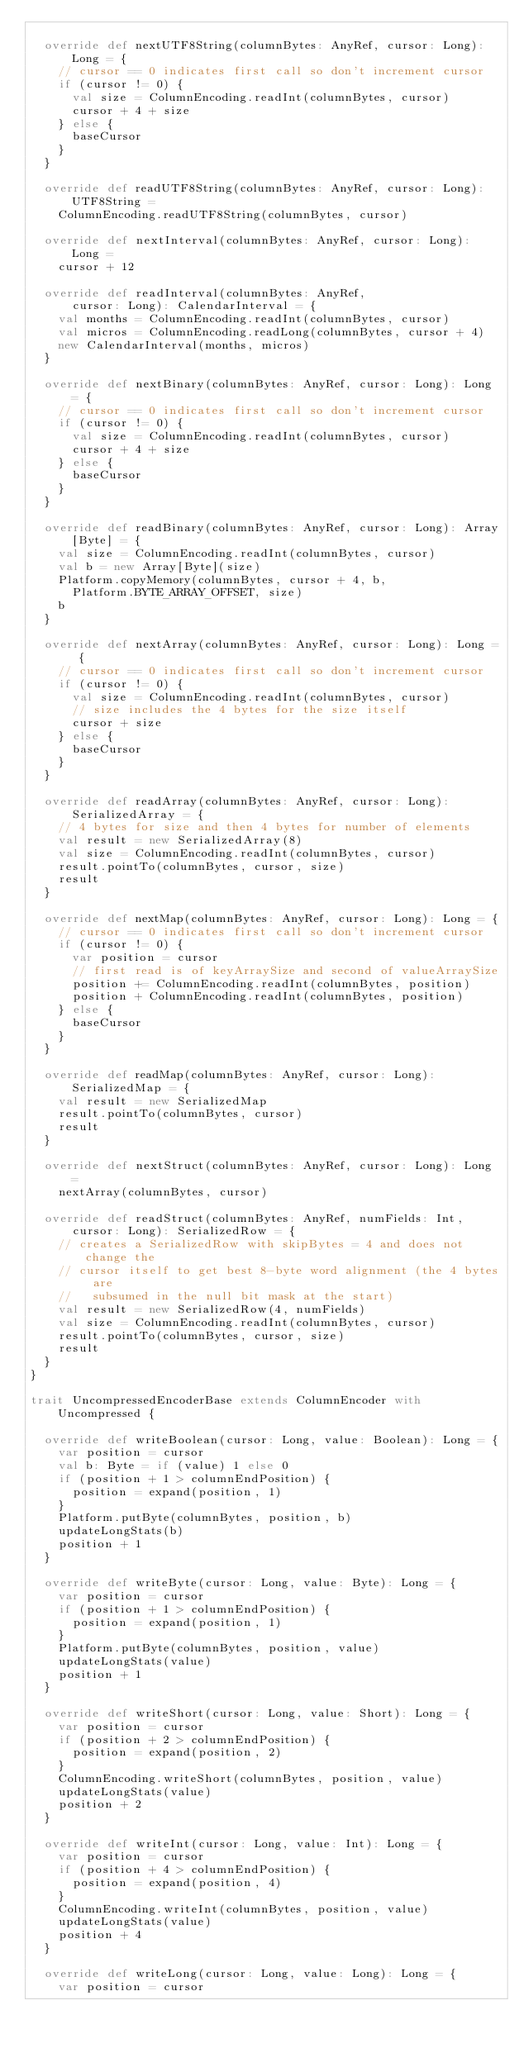<code> <loc_0><loc_0><loc_500><loc_500><_Scala_>
  override def nextUTF8String(columnBytes: AnyRef, cursor: Long): Long = {
    // cursor == 0 indicates first call so don't increment cursor
    if (cursor != 0) {
      val size = ColumnEncoding.readInt(columnBytes, cursor)
      cursor + 4 + size
    } else {
      baseCursor
    }
  }

  override def readUTF8String(columnBytes: AnyRef, cursor: Long): UTF8String =
    ColumnEncoding.readUTF8String(columnBytes, cursor)

  override def nextInterval(columnBytes: AnyRef, cursor: Long): Long =
    cursor + 12

  override def readInterval(columnBytes: AnyRef,
      cursor: Long): CalendarInterval = {
    val months = ColumnEncoding.readInt(columnBytes, cursor)
    val micros = ColumnEncoding.readLong(columnBytes, cursor + 4)
    new CalendarInterval(months, micros)
  }

  override def nextBinary(columnBytes: AnyRef, cursor: Long): Long = {
    // cursor == 0 indicates first call so don't increment cursor
    if (cursor != 0) {
      val size = ColumnEncoding.readInt(columnBytes, cursor)
      cursor + 4 + size
    } else {
      baseCursor
    }
  }

  override def readBinary(columnBytes: AnyRef, cursor: Long): Array[Byte] = {
    val size = ColumnEncoding.readInt(columnBytes, cursor)
    val b = new Array[Byte](size)
    Platform.copyMemory(columnBytes, cursor + 4, b,
      Platform.BYTE_ARRAY_OFFSET, size)
    b
  }

  override def nextArray(columnBytes: AnyRef, cursor: Long): Long = {
    // cursor == 0 indicates first call so don't increment cursor
    if (cursor != 0) {
      val size = ColumnEncoding.readInt(columnBytes, cursor)
      // size includes the 4 bytes for the size itself
      cursor + size
    } else {
      baseCursor
    }
  }

  override def readArray(columnBytes: AnyRef, cursor: Long): SerializedArray = {
    // 4 bytes for size and then 4 bytes for number of elements
    val result = new SerializedArray(8)
    val size = ColumnEncoding.readInt(columnBytes, cursor)
    result.pointTo(columnBytes, cursor, size)
    result
  }

  override def nextMap(columnBytes: AnyRef, cursor: Long): Long = {
    // cursor == 0 indicates first call so don't increment cursor
    if (cursor != 0) {
      var position = cursor
      // first read is of keyArraySize and second of valueArraySize
      position += ColumnEncoding.readInt(columnBytes, position)
      position + ColumnEncoding.readInt(columnBytes, position)
    } else {
      baseCursor
    }
  }

  override def readMap(columnBytes: AnyRef, cursor: Long): SerializedMap = {
    val result = new SerializedMap
    result.pointTo(columnBytes, cursor)
    result
  }

  override def nextStruct(columnBytes: AnyRef, cursor: Long): Long =
    nextArray(columnBytes, cursor)

  override def readStruct(columnBytes: AnyRef, numFields: Int,
      cursor: Long): SerializedRow = {
    // creates a SerializedRow with skipBytes = 4 and does not change the
    // cursor itself to get best 8-byte word alignment (the 4 bytes are
    //   subsumed in the null bit mask at the start)
    val result = new SerializedRow(4, numFields)
    val size = ColumnEncoding.readInt(columnBytes, cursor)
    result.pointTo(columnBytes, cursor, size)
    result
  }
}

trait UncompressedEncoderBase extends ColumnEncoder with Uncompressed {

  override def writeBoolean(cursor: Long, value: Boolean): Long = {
    var position = cursor
    val b: Byte = if (value) 1 else 0
    if (position + 1 > columnEndPosition) {
      position = expand(position, 1)
    }
    Platform.putByte(columnBytes, position, b)
    updateLongStats(b)
    position + 1
  }

  override def writeByte(cursor: Long, value: Byte): Long = {
    var position = cursor
    if (position + 1 > columnEndPosition) {
      position = expand(position, 1)
    }
    Platform.putByte(columnBytes, position, value)
    updateLongStats(value)
    position + 1
  }

  override def writeShort(cursor: Long, value: Short): Long = {
    var position = cursor
    if (position + 2 > columnEndPosition) {
      position = expand(position, 2)
    }
    ColumnEncoding.writeShort(columnBytes, position, value)
    updateLongStats(value)
    position + 2
  }

  override def writeInt(cursor: Long, value: Int): Long = {
    var position = cursor
    if (position + 4 > columnEndPosition) {
      position = expand(position, 4)
    }
    ColumnEncoding.writeInt(columnBytes, position, value)
    updateLongStats(value)
    position + 4
  }

  override def writeLong(cursor: Long, value: Long): Long = {
    var position = cursor</code> 